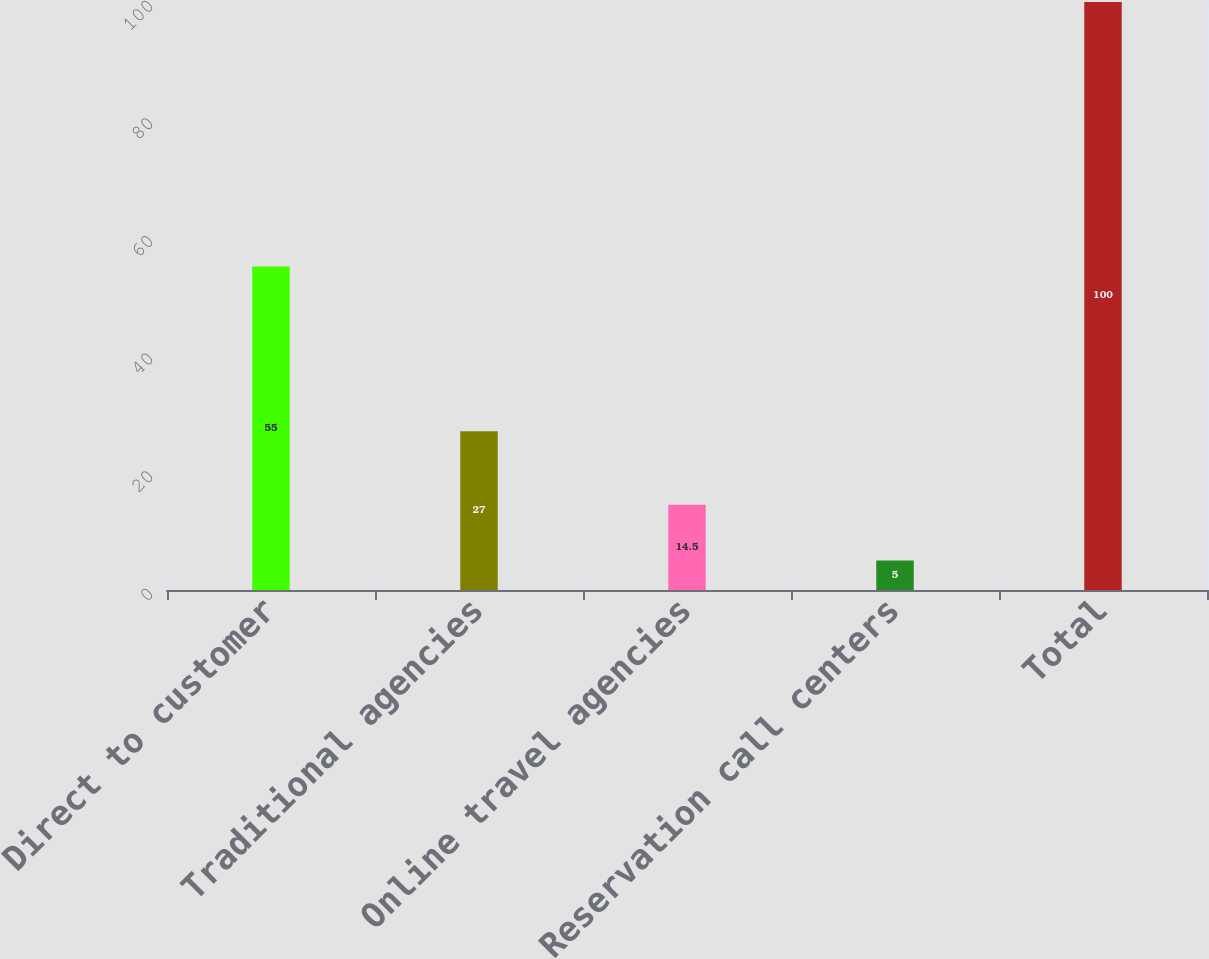Convert chart. <chart><loc_0><loc_0><loc_500><loc_500><bar_chart><fcel>Direct to customer<fcel>Traditional agencies<fcel>Online travel agencies<fcel>Reservation call centers<fcel>Total<nl><fcel>55<fcel>27<fcel>14.5<fcel>5<fcel>100<nl></chart> 